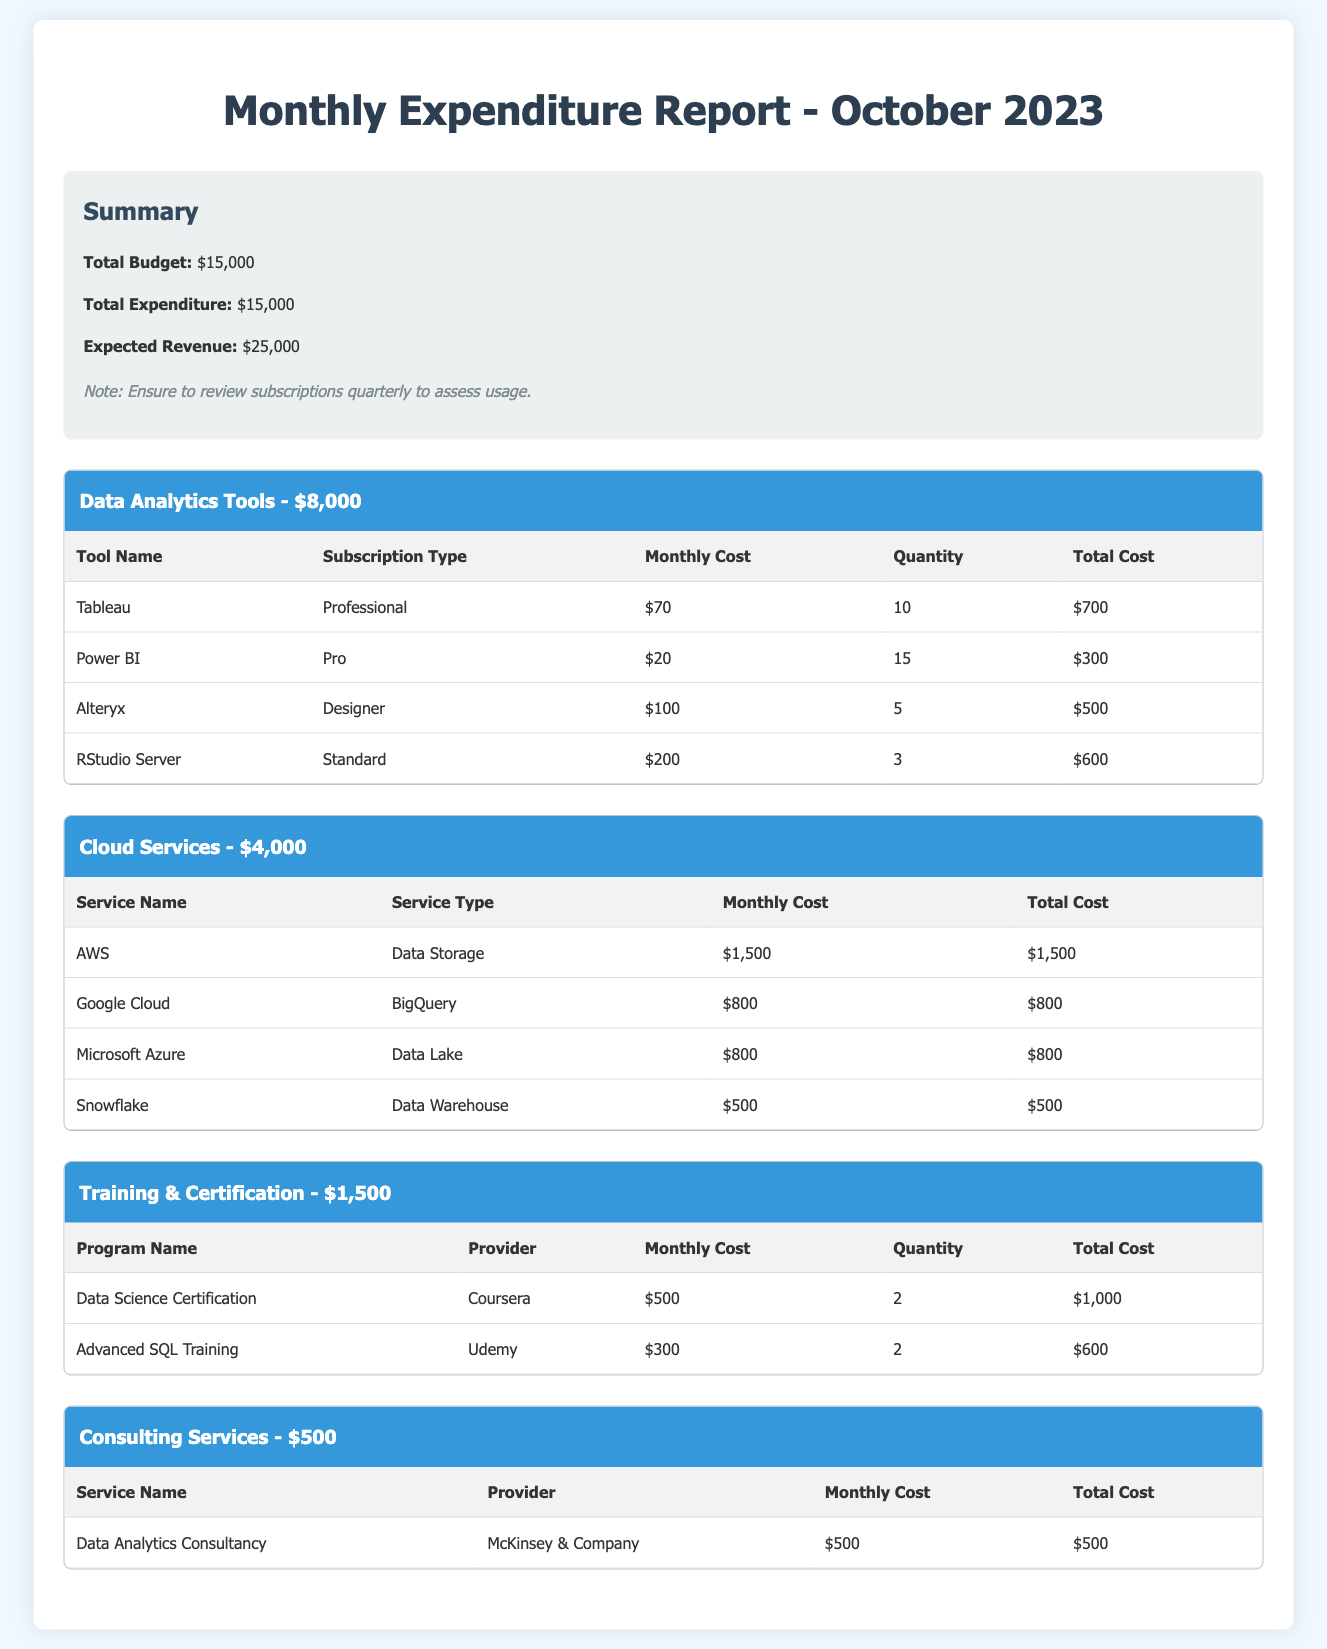what is the total budget? The total budget is stated in the summary section of the document.
Answer: $15,000 what is the total expenditure? The total expenditure is mentioned in the summary section of the document.
Answer: $15,000 how much is allocated for Data Analytics Tools? The allocation for Data Analytics Tools is provided in the category section.
Answer: $8,000 which tool has the highest monthly cost? The tool with the highest monthly cost can be found in the Data Analytics Tools category.
Answer: RStudio Server how many subscriptions are there for Power BI? The number of subscriptions for Power BI is listed in the Data Analytics Tools table.
Answer: 15 what is the total cost for AWS? The total cost for AWS is calculated in the Cloud Services category.
Answer: $1,500 who is the provider for Data Science Certification? The provider for Data Science Certification is mentioned in the Training & Certification category.
Answer: Coursera what is the total cost for Training & Certification? The total cost for Training & Certification is provided in the category header.
Answer: $1,500 how many training programs are listed? The number of training programs can be counted from the Training & Certification table.
Answer: 2 